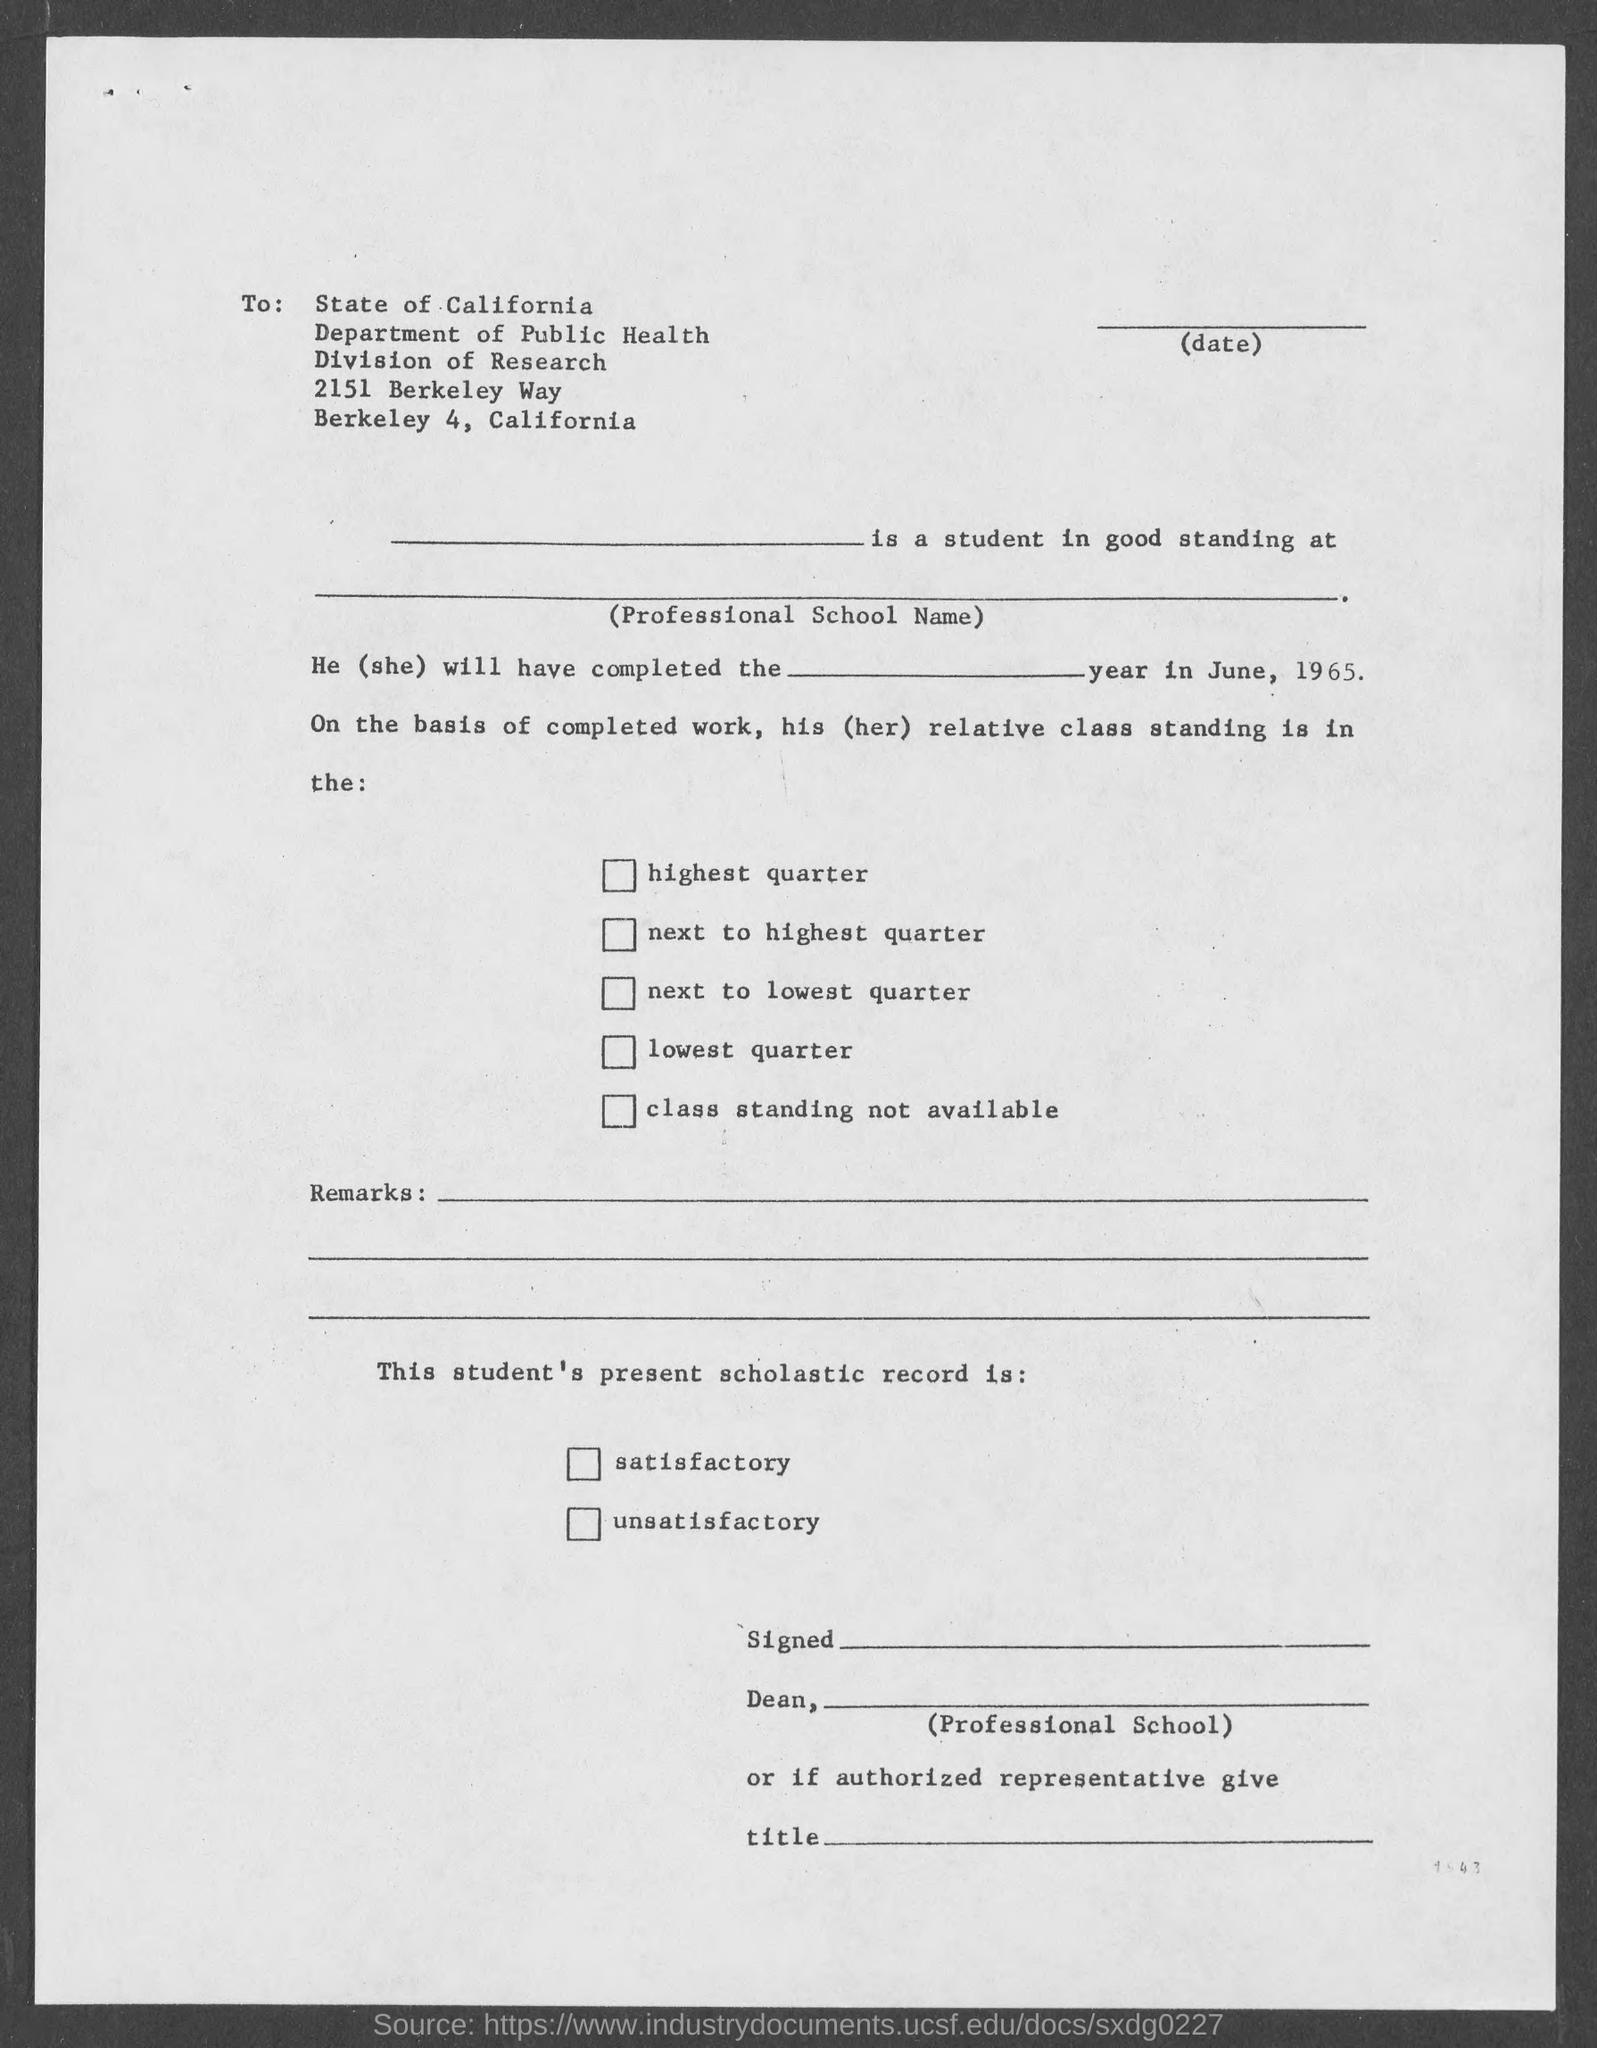Point out several critical features in this image. The division mentioned in the given form refers to the division of research. The given form mentions a department named "Department of Public Health. 